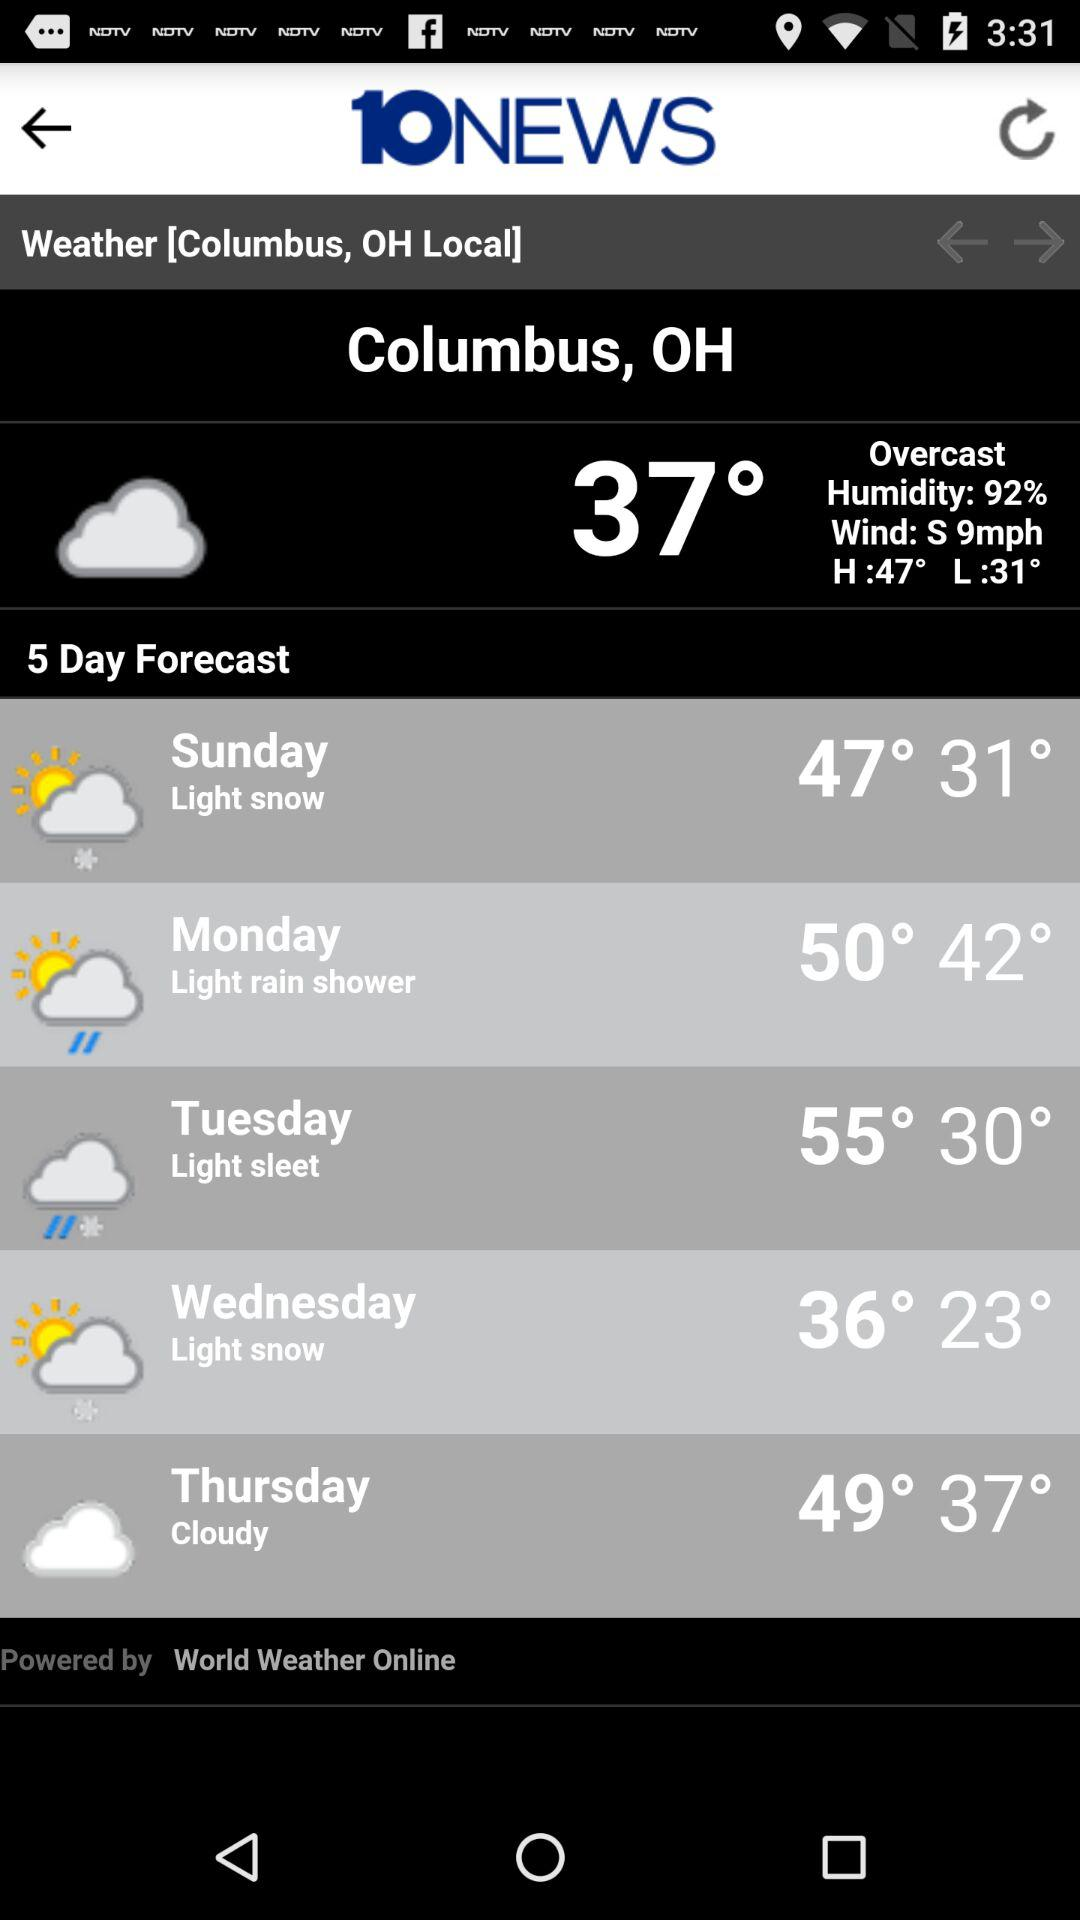The weather forecast is given for which place? The weather forecast is given for Columbus, OH. 